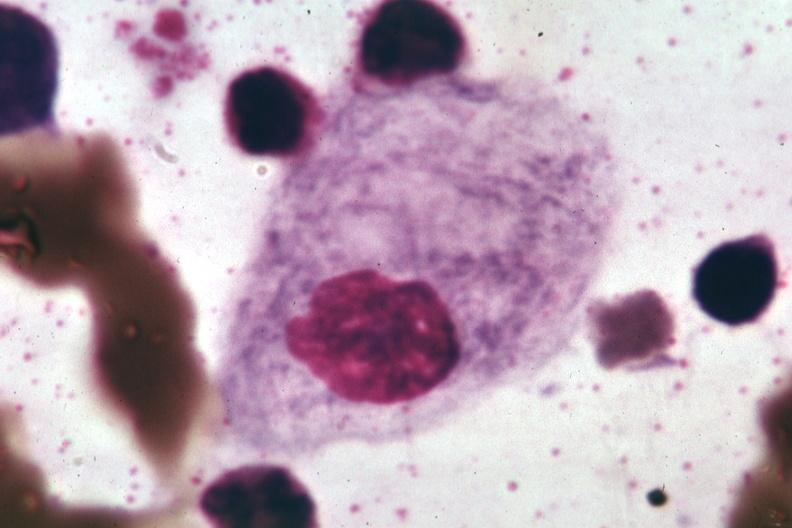what is present?
Answer the question using a single word or phrase. Bone marrow 